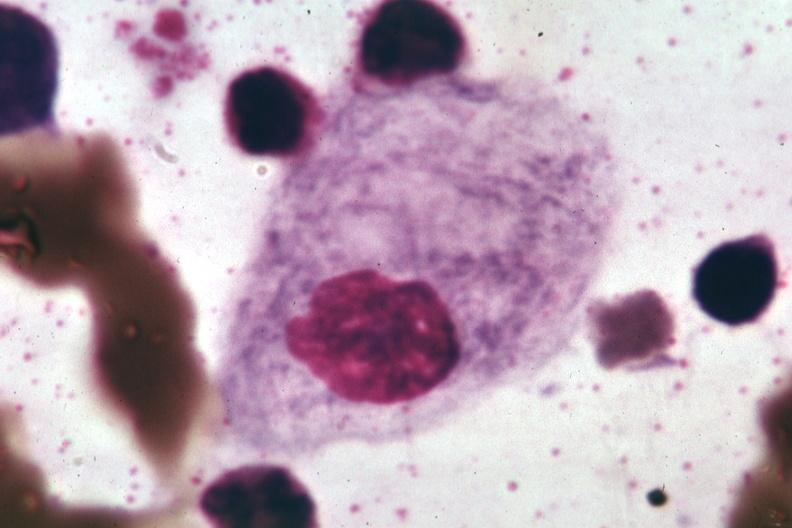what is present?
Answer the question using a single word or phrase. Bone marrow 